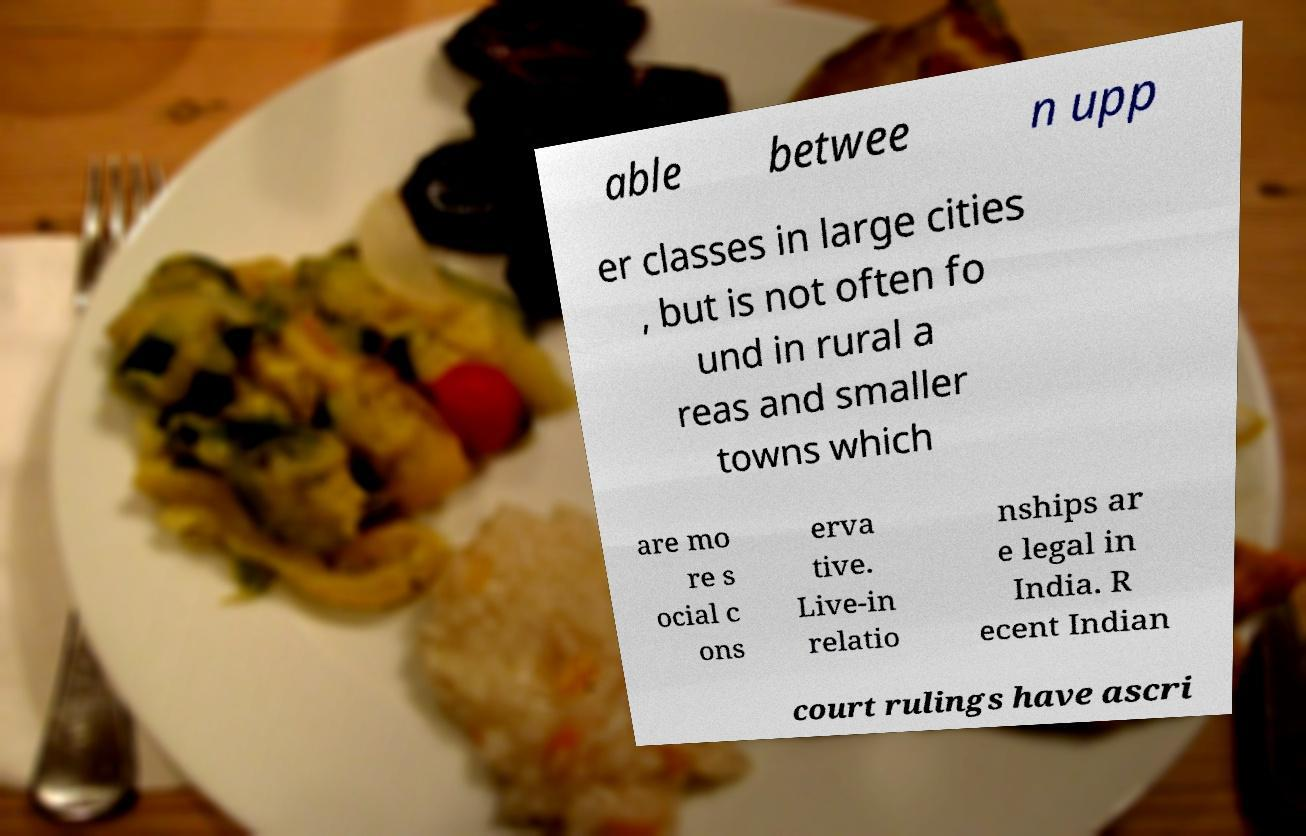Can you accurately transcribe the text from the provided image for me? able betwee n upp er classes in large cities , but is not often fo und in rural a reas and smaller towns which are mo re s ocial c ons erva tive. Live-in relatio nships ar e legal in India. R ecent Indian court rulings have ascri 